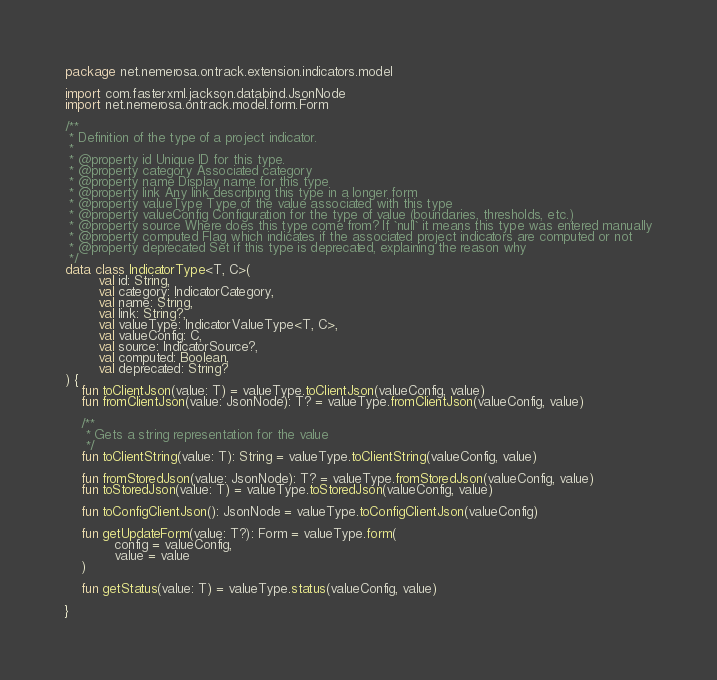Convert code to text. <code><loc_0><loc_0><loc_500><loc_500><_Kotlin_>package net.nemerosa.ontrack.extension.indicators.model

import com.fasterxml.jackson.databind.JsonNode
import net.nemerosa.ontrack.model.form.Form

/**
 * Definition of the type of a project indicator.
 *
 * @property id Unique ID for this type.
 * @property category Associated category
 * @property name Display name for this type
 * @property link Any link describing this type in a longer form
 * @property valueType Type of the value associated with this type
 * @property valueConfig Configuration for the type of value (boundaries, thresholds, etc.)
 * @property source Where does this type come from? If `null` it means this type was entered manually
 * @property computed Flag which indicates if the associated project indicators are computed or not
 * @property deprecated Set if this type is deprecated, explaining the reason why
 */
data class IndicatorType<T, C>(
        val id: String,
        val category: IndicatorCategory,
        val name: String,
        val link: String?,
        val valueType: IndicatorValueType<T, C>,
        val valueConfig: C,
        val source: IndicatorSource?,
        val computed: Boolean,
        val deprecated: String?
) {
    fun toClientJson(value: T) = valueType.toClientJson(valueConfig, value)
    fun fromClientJson(value: JsonNode): T? = valueType.fromClientJson(valueConfig, value)

    /**
     * Gets a string representation for the value
     */
    fun toClientString(value: T): String = valueType.toClientString(valueConfig, value)

    fun fromStoredJson(value: JsonNode): T? = valueType.fromStoredJson(valueConfig, value)
    fun toStoredJson(value: T) = valueType.toStoredJson(valueConfig, value)

    fun toConfigClientJson(): JsonNode = valueType.toConfigClientJson(valueConfig)

    fun getUpdateForm(value: T?): Form = valueType.form(
            config = valueConfig,
            value = value
    )

    fun getStatus(value: T) = valueType.status(valueConfig, value)

}
</code> 